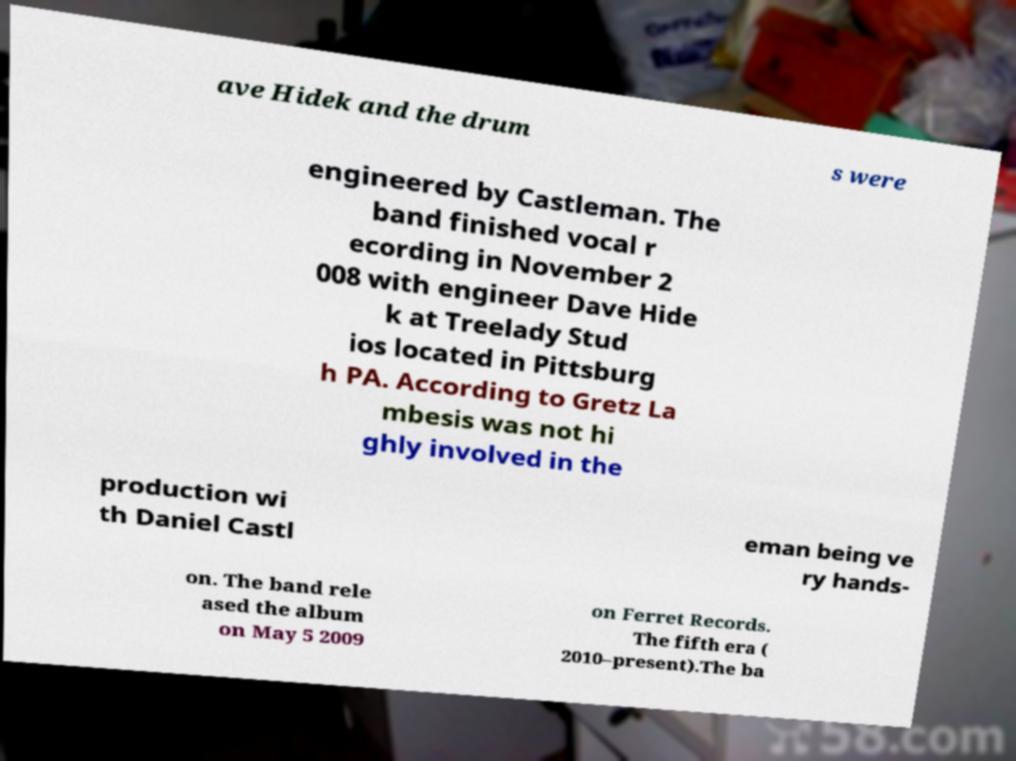Please identify and transcribe the text found in this image. ave Hidek and the drum s were engineered by Castleman. The band finished vocal r ecording in November 2 008 with engineer Dave Hide k at Treelady Stud ios located in Pittsburg h PA. According to Gretz La mbesis was not hi ghly involved in the production wi th Daniel Castl eman being ve ry hands- on. The band rele ased the album on May 5 2009 on Ferret Records. The fifth era ( 2010–present).The ba 